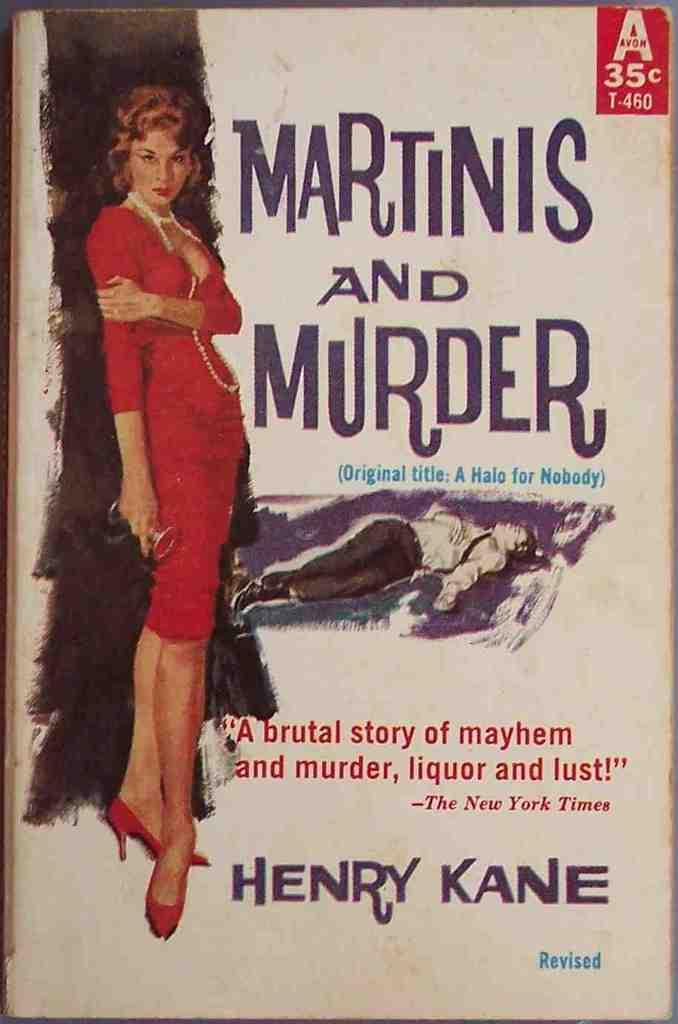<image>
Present a compact description of the photo's key features. The book cover of Martines and Murder, by Henry Kane, shows the original price as 35 cents. 